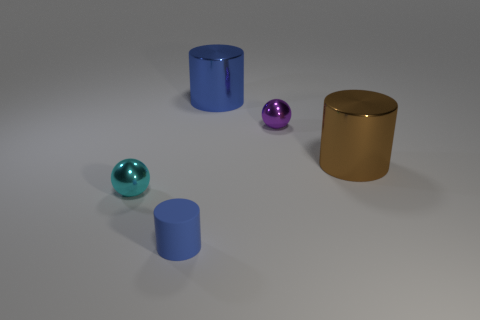The rubber cylinder is what color?
Make the answer very short. Blue. What number of other objects are there of the same material as the tiny cyan ball?
Give a very brief answer. 3. What number of cyan objects are either big metal cylinders or small matte cylinders?
Offer a very short reply. 0. There is a tiny thing that is behind the tiny cyan sphere; is its shape the same as the big thing behind the brown cylinder?
Make the answer very short. No. Do the small rubber cylinder and the tiny ball right of the tiny blue matte cylinder have the same color?
Ensure brevity in your answer.  No. There is a small ball that is on the right side of the tiny cylinder; is it the same color as the matte thing?
Offer a very short reply. No. What number of objects are tiny cyan metallic spheres or small blue matte cylinders that are in front of the small purple metallic thing?
Your response must be concise. 2. What material is the thing that is both on the right side of the cyan sphere and to the left of the blue metallic cylinder?
Give a very brief answer. Rubber. What material is the small object that is to the left of the small cylinder?
Your response must be concise. Metal. There is a big cylinder that is made of the same material as the large blue thing; what is its color?
Make the answer very short. Brown. 